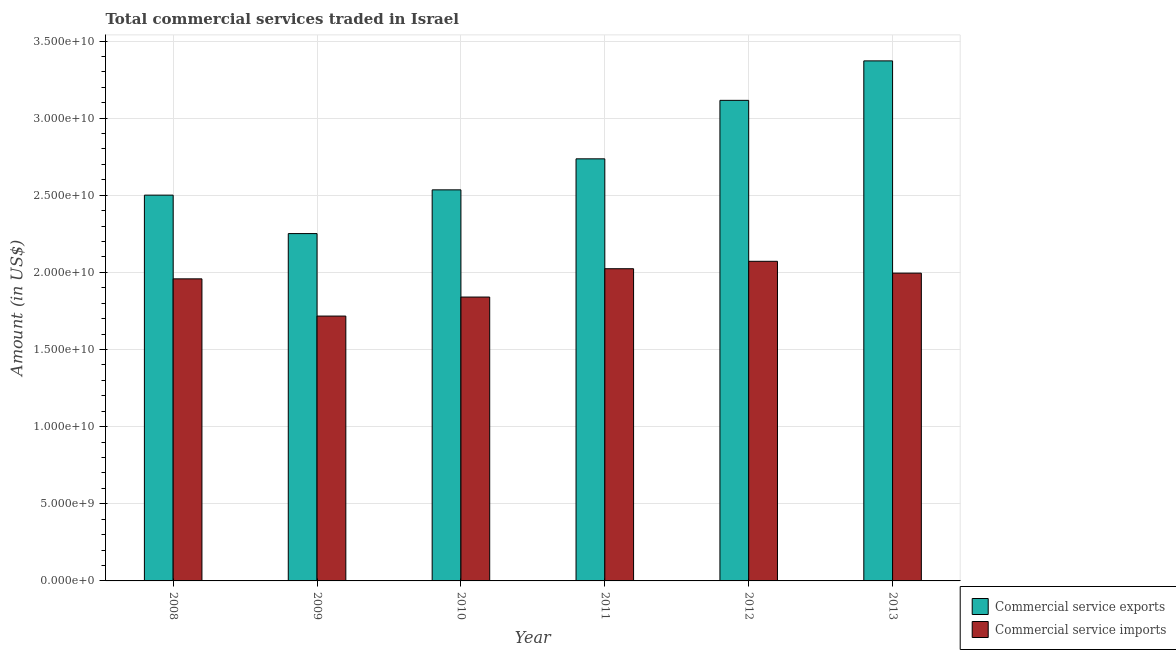How many different coloured bars are there?
Keep it short and to the point. 2. How many groups of bars are there?
Give a very brief answer. 6. Are the number of bars on each tick of the X-axis equal?
Provide a short and direct response. Yes. In how many cases, is the number of bars for a given year not equal to the number of legend labels?
Make the answer very short. 0. What is the amount of commercial service exports in 2011?
Keep it short and to the point. 2.74e+1. Across all years, what is the maximum amount of commercial service exports?
Your response must be concise. 3.37e+1. Across all years, what is the minimum amount of commercial service exports?
Provide a short and direct response. 2.25e+1. In which year was the amount of commercial service imports maximum?
Your answer should be very brief. 2012. What is the total amount of commercial service exports in the graph?
Offer a very short reply. 1.65e+11. What is the difference between the amount of commercial service exports in 2012 and that in 2013?
Your answer should be very brief. -2.56e+09. What is the difference between the amount of commercial service imports in 2013 and the amount of commercial service exports in 2011?
Your answer should be compact. -2.86e+08. What is the average amount of commercial service imports per year?
Offer a very short reply. 1.93e+1. In the year 2008, what is the difference between the amount of commercial service exports and amount of commercial service imports?
Keep it short and to the point. 0. In how many years, is the amount of commercial service imports greater than 8000000000 US$?
Give a very brief answer. 6. What is the ratio of the amount of commercial service imports in 2009 to that in 2011?
Your answer should be very brief. 0.85. Is the amount of commercial service exports in 2011 less than that in 2012?
Give a very brief answer. Yes. What is the difference between the highest and the second highest amount of commercial service exports?
Your answer should be very brief. 2.56e+09. What is the difference between the highest and the lowest amount of commercial service imports?
Your answer should be very brief. 3.55e+09. In how many years, is the amount of commercial service exports greater than the average amount of commercial service exports taken over all years?
Offer a terse response. 2. What does the 1st bar from the left in 2013 represents?
Your answer should be very brief. Commercial service exports. What does the 2nd bar from the right in 2008 represents?
Offer a terse response. Commercial service exports. Are all the bars in the graph horizontal?
Offer a very short reply. No. How many years are there in the graph?
Your answer should be compact. 6. Are the values on the major ticks of Y-axis written in scientific E-notation?
Keep it short and to the point. Yes. Does the graph contain any zero values?
Provide a succinct answer. No. Where does the legend appear in the graph?
Offer a very short reply. Bottom right. How are the legend labels stacked?
Provide a short and direct response. Vertical. What is the title of the graph?
Provide a short and direct response. Total commercial services traded in Israel. What is the label or title of the X-axis?
Provide a succinct answer. Year. What is the label or title of the Y-axis?
Your answer should be very brief. Amount (in US$). What is the Amount (in US$) of Commercial service exports in 2008?
Make the answer very short. 2.50e+1. What is the Amount (in US$) of Commercial service imports in 2008?
Your answer should be compact. 1.96e+1. What is the Amount (in US$) in Commercial service exports in 2009?
Provide a short and direct response. 2.25e+1. What is the Amount (in US$) in Commercial service imports in 2009?
Keep it short and to the point. 1.72e+1. What is the Amount (in US$) in Commercial service exports in 2010?
Provide a succinct answer. 2.54e+1. What is the Amount (in US$) of Commercial service imports in 2010?
Provide a succinct answer. 1.84e+1. What is the Amount (in US$) in Commercial service exports in 2011?
Ensure brevity in your answer.  2.74e+1. What is the Amount (in US$) of Commercial service imports in 2011?
Your answer should be compact. 2.02e+1. What is the Amount (in US$) of Commercial service exports in 2012?
Provide a succinct answer. 3.12e+1. What is the Amount (in US$) of Commercial service imports in 2012?
Offer a terse response. 2.07e+1. What is the Amount (in US$) in Commercial service exports in 2013?
Keep it short and to the point. 3.37e+1. What is the Amount (in US$) of Commercial service imports in 2013?
Make the answer very short. 2.00e+1. Across all years, what is the maximum Amount (in US$) of Commercial service exports?
Your response must be concise. 3.37e+1. Across all years, what is the maximum Amount (in US$) of Commercial service imports?
Provide a short and direct response. 2.07e+1. Across all years, what is the minimum Amount (in US$) of Commercial service exports?
Offer a terse response. 2.25e+1. Across all years, what is the minimum Amount (in US$) of Commercial service imports?
Offer a terse response. 1.72e+1. What is the total Amount (in US$) of Commercial service exports in the graph?
Offer a very short reply. 1.65e+11. What is the total Amount (in US$) in Commercial service imports in the graph?
Offer a terse response. 1.16e+11. What is the difference between the Amount (in US$) in Commercial service exports in 2008 and that in 2009?
Provide a short and direct response. 2.49e+09. What is the difference between the Amount (in US$) of Commercial service imports in 2008 and that in 2009?
Provide a short and direct response. 2.41e+09. What is the difference between the Amount (in US$) of Commercial service exports in 2008 and that in 2010?
Offer a terse response. -3.42e+08. What is the difference between the Amount (in US$) of Commercial service imports in 2008 and that in 2010?
Your response must be concise. 1.18e+09. What is the difference between the Amount (in US$) in Commercial service exports in 2008 and that in 2011?
Your response must be concise. -2.35e+09. What is the difference between the Amount (in US$) of Commercial service imports in 2008 and that in 2011?
Make the answer very short. -6.57e+08. What is the difference between the Amount (in US$) of Commercial service exports in 2008 and that in 2012?
Ensure brevity in your answer.  -6.14e+09. What is the difference between the Amount (in US$) of Commercial service imports in 2008 and that in 2012?
Keep it short and to the point. -1.14e+09. What is the difference between the Amount (in US$) of Commercial service exports in 2008 and that in 2013?
Provide a succinct answer. -8.70e+09. What is the difference between the Amount (in US$) in Commercial service imports in 2008 and that in 2013?
Ensure brevity in your answer.  -3.71e+08. What is the difference between the Amount (in US$) in Commercial service exports in 2009 and that in 2010?
Offer a very short reply. -2.83e+09. What is the difference between the Amount (in US$) of Commercial service imports in 2009 and that in 2010?
Keep it short and to the point. -1.23e+09. What is the difference between the Amount (in US$) of Commercial service exports in 2009 and that in 2011?
Make the answer very short. -4.85e+09. What is the difference between the Amount (in US$) of Commercial service imports in 2009 and that in 2011?
Offer a terse response. -3.07e+09. What is the difference between the Amount (in US$) of Commercial service exports in 2009 and that in 2012?
Your response must be concise. -8.64e+09. What is the difference between the Amount (in US$) in Commercial service imports in 2009 and that in 2012?
Provide a short and direct response. -3.55e+09. What is the difference between the Amount (in US$) of Commercial service exports in 2009 and that in 2013?
Offer a very short reply. -1.12e+1. What is the difference between the Amount (in US$) of Commercial service imports in 2009 and that in 2013?
Make the answer very short. -2.78e+09. What is the difference between the Amount (in US$) of Commercial service exports in 2010 and that in 2011?
Offer a very short reply. -2.01e+09. What is the difference between the Amount (in US$) in Commercial service imports in 2010 and that in 2011?
Your response must be concise. -1.84e+09. What is the difference between the Amount (in US$) in Commercial service exports in 2010 and that in 2012?
Give a very brief answer. -5.80e+09. What is the difference between the Amount (in US$) of Commercial service imports in 2010 and that in 2012?
Your response must be concise. -2.32e+09. What is the difference between the Amount (in US$) of Commercial service exports in 2010 and that in 2013?
Your answer should be compact. -8.36e+09. What is the difference between the Amount (in US$) of Commercial service imports in 2010 and that in 2013?
Keep it short and to the point. -1.55e+09. What is the difference between the Amount (in US$) in Commercial service exports in 2011 and that in 2012?
Offer a very short reply. -3.79e+09. What is the difference between the Amount (in US$) of Commercial service imports in 2011 and that in 2012?
Provide a short and direct response. -4.81e+08. What is the difference between the Amount (in US$) of Commercial service exports in 2011 and that in 2013?
Keep it short and to the point. -6.35e+09. What is the difference between the Amount (in US$) in Commercial service imports in 2011 and that in 2013?
Give a very brief answer. 2.86e+08. What is the difference between the Amount (in US$) of Commercial service exports in 2012 and that in 2013?
Offer a very short reply. -2.56e+09. What is the difference between the Amount (in US$) in Commercial service imports in 2012 and that in 2013?
Provide a succinct answer. 7.67e+08. What is the difference between the Amount (in US$) in Commercial service exports in 2008 and the Amount (in US$) in Commercial service imports in 2009?
Your response must be concise. 7.84e+09. What is the difference between the Amount (in US$) in Commercial service exports in 2008 and the Amount (in US$) in Commercial service imports in 2010?
Ensure brevity in your answer.  6.61e+09. What is the difference between the Amount (in US$) in Commercial service exports in 2008 and the Amount (in US$) in Commercial service imports in 2011?
Give a very brief answer. 4.77e+09. What is the difference between the Amount (in US$) in Commercial service exports in 2008 and the Amount (in US$) in Commercial service imports in 2012?
Make the answer very short. 4.29e+09. What is the difference between the Amount (in US$) of Commercial service exports in 2008 and the Amount (in US$) of Commercial service imports in 2013?
Provide a succinct answer. 5.06e+09. What is the difference between the Amount (in US$) in Commercial service exports in 2009 and the Amount (in US$) in Commercial service imports in 2010?
Offer a very short reply. 4.11e+09. What is the difference between the Amount (in US$) of Commercial service exports in 2009 and the Amount (in US$) of Commercial service imports in 2011?
Ensure brevity in your answer.  2.28e+09. What is the difference between the Amount (in US$) of Commercial service exports in 2009 and the Amount (in US$) of Commercial service imports in 2012?
Give a very brief answer. 1.80e+09. What is the difference between the Amount (in US$) of Commercial service exports in 2009 and the Amount (in US$) of Commercial service imports in 2013?
Your answer should be very brief. 2.56e+09. What is the difference between the Amount (in US$) in Commercial service exports in 2010 and the Amount (in US$) in Commercial service imports in 2011?
Keep it short and to the point. 5.11e+09. What is the difference between the Amount (in US$) of Commercial service exports in 2010 and the Amount (in US$) of Commercial service imports in 2012?
Your response must be concise. 4.63e+09. What is the difference between the Amount (in US$) of Commercial service exports in 2010 and the Amount (in US$) of Commercial service imports in 2013?
Offer a terse response. 5.40e+09. What is the difference between the Amount (in US$) in Commercial service exports in 2011 and the Amount (in US$) in Commercial service imports in 2012?
Make the answer very short. 6.64e+09. What is the difference between the Amount (in US$) in Commercial service exports in 2011 and the Amount (in US$) in Commercial service imports in 2013?
Offer a very short reply. 7.41e+09. What is the difference between the Amount (in US$) of Commercial service exports in 2012 and the Amount (in US$) of Commercial service imports in 2013?
Make the answer very short. 1.12e+1. What is the average Amount (in US$) of Commercial service exports per year?
Ensure brevity in your answer.  2.75e+1. What is the average Amount (in US$) in Commercial service imports per year?
Provide a succinct answer. 1.93e+1. In the year 2008, what is the difference between the Amount (in US$) of Commercial service exports and Amount (in US$) of Commercial service imports?
Offer a terse response. 5.43e+09. In the year 2009, what is the difference between the Amount (in US$) of Commercial service exports and Amount (in US$) of Commercial service imports?
Your answer should be compact. 5.35e+09. In the year 2010, what is the difference between the Amount (in US$) of Commercial service exports and Amount (in US$) of Commercial service imports?
Make the answer very short. 6.95e+09. In the year 2011, what is the difference between the Amount (in US$) in Commercial service exports and Amount (in US$) in Commercial service imports?
Your response must be concise. 7.12e+09. In the year 2012, what is the difference between the Amount (in US$) of Commercial service exports and Amount (in US$) of Commercial service imports?
Offer a terse response. 1.04e+1. In the year 2013, what is the difference between the Amount (in US$) in Commercial service exports and Amount (in US$) in Commercial service imports?
Your answer should be compact. 1.38e+1. What is the ratio of the Amount (in US$) in Commercial service exports in 2008 to that in 2009?
Your answer should be compact. 1.11. What is the ratio of the Amount (in US$) of Commercial service imports in 2008 to that in 2009?
Your answer should be very brief. 1.14. What is the ratio of the Amount (in US$) of Commercial service exports in 2008 to that in 2010?
Your answer should be compact. 0.99. What is the ratio of the Amount (in US$) in Commercial service imports in 2008 to that in 2010?
Provide a succinct answer. 1.06. What is the ratio of the Amount (in US$) in Commercial service exports in 2008 to that in 2011?
Give a very brief answer. 0.91. What is the ratio of the Amount (in US$) in Commercial service imports in 2008 to that in 2011?
Offer a very short reply. 0.97. What is the ratio of the Amount (in US$) in Commercial service exports in 2008 to that in 2012?
Make the answer very short. 0.8. What is the ratio of the Amount (in US$) in Commercial service imports in 2008 to that in 2012?
Your answer should be compact. 0.95. What is the ratio of the Amount (in US$) of Commercial service exports in 2008 to that in 2013?
Your response must be concise. 0.74. What is the ratio of the Amount (in US$) of Commercial service imports in 2008 to that in 2013?
Your answer should be compact. 0.98. What is the ratio of the Amount (in US$) of Commercial service exports in 2009 to that in 2010?
Keep it short and to the point. 0.89. What is the ratio of the Amount (in US$) of Commercial service imports in 2009 to that in 2010?
Provide a succinct answer. 0.93. What is the ratio of the Amount (in US$) in Commercial service exports in 2009 to that in 2011?
Your answer should be very brief. 0.82. What is the ratio of the Amount (in US$) in Commercial service imports in 2009 to that in 2011?
Your response must be concise. 0.85. What is the ratio of the Amount (in US$) of Commercial service exports in 2009 to that in 2012?
Keep it short and to the point. 0.72. What is the ratio of the Amount (in US$) of Commercial service imports in 2009 to that in 2012?
Make the answer very short. 0.83. What is the ratio of the Amount (in US$) in Commercial service exports in 2009 to that in 2013?
Make the answer very short. 0.67. What is the ratio of the Amount (in US$) of Commercial service imports in 2009 to that in 2013?
Your response must be concise. 0.86. What is the ratio of the Amount (in US$) of Commercial service exports in 2010 to that in 2011?
Give a very brief answer. 0.93. What is the ratio of the Amount (in US$) of Commercial service imports in 2010 to that in 2011?
Provide a short and direct response. 0.91. What is the ratio of the Amount (in US$) of Commercial service exports in 2010 to that in 2012?
Offer a terse response. 0.81. What is the ratio of the Amount (in US$) in Commercial service imports in 2010 to that in 2012?
Provide a short and direct response. 0.89. What is the ratio of the Amount (in US$) of Commercial service exports in 2010 to that in 2013?
Keep it short and to the point. 0.75. What is the ratio of the Amount (in US$) in Commercial service imports in 2010 to that in 2013?
Provide a succinct answer. 0.92. What is the ratio of the Amount (in US$) in Commercial service exports in 2011 to that in 2012?
Your answer should be very brief. 0.88. What is the ratio of the Amount (in US$) of Commercial service imports in 2011 to that in 2012?
Your answer should be very brief. 0.98. What is the ratio of the Amount (in US$) of Commercial service exports in 2011 to that in 2013?
Make the answer very short. 0.81. What is the ratio of the Amount (in US$) in Commercial service imports in 2011 to that in 2013?
Make the answer very short. 1.01. What is the ratio of the Amount (in US$) of Commercial service exports in 2012 to that in 2013?
Your answer should be very brief. 0.92. What is the difference between the highest and the second highest Amount (in US$) of Commercial service exports?
Your response must be concise. 2.56e+09. What is the difference between the highest and the second highest Amount (in US$) of Commercial service imports?
Your answer should be very brief. 4.81e+08. What is the difference between the highest and the lowest Amount (in US$) of Commercial service exports?
Give a very brief answer. 1.12e+1. What is the difference between the highest and the lowest Amount (in US$) of Commercial service imports?
Ensure brevity in your answer.  3.55e+09. 